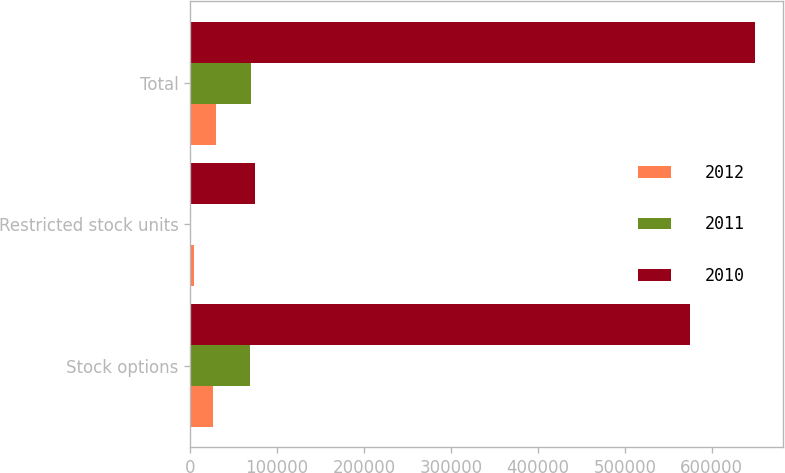Convert chart to OTSL. <chart><loc_0><loc_0><loc_500><loc_500><stacked_bar_chart><ecel><fcel>Stock options<fcel>Restricted stock units<fcel>Total<nl><fcel>2012<fcel>25906<fcel>3996<fcel>29902<nl><fcel>2011<fcel>69395<fcel>735<fcel>70130<nl><fcel>2010<fcel>575266<fcel>74166<fcel>649432<nl></chart> 